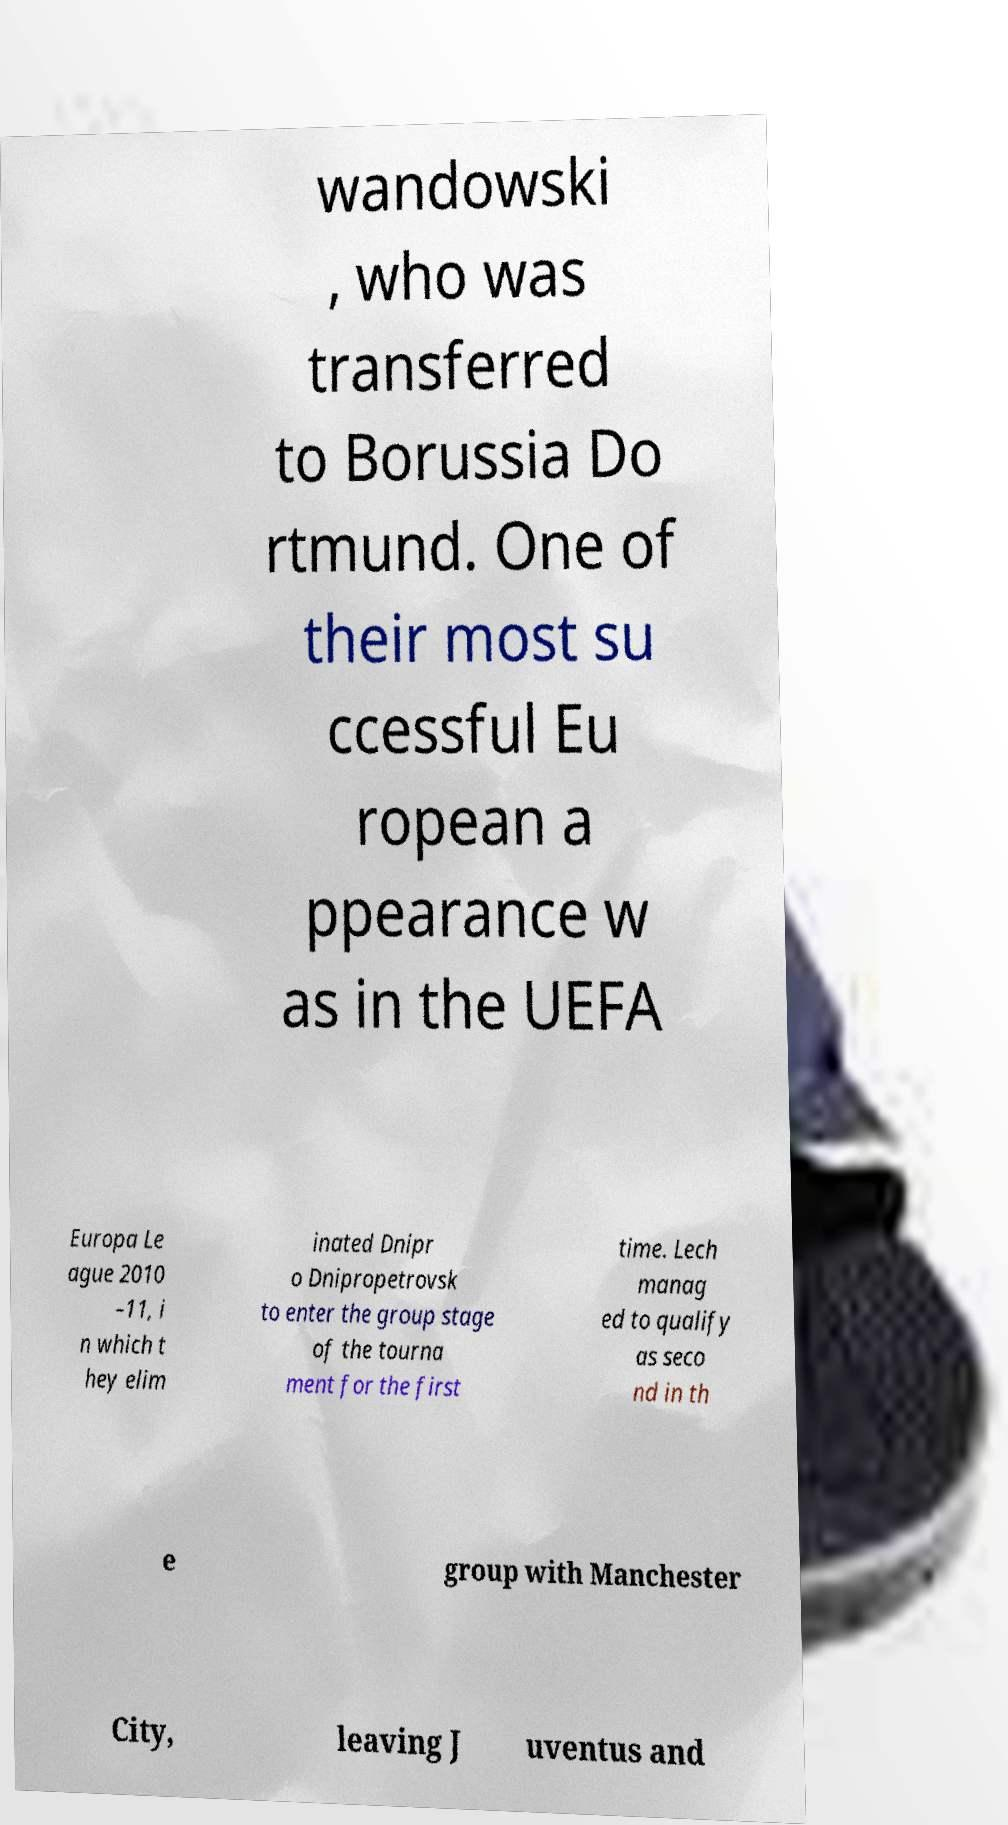Can you accurately transcribe the text from the provided image for me? wandowski , who was transferred to Borussia Do rtmund. One of their most su ccessful Eu ropean a ppearance w as in the UEFA Europa Le ague 2010 –11, i n which t hey elim inated Dnipr o Dnipropetrovsk to enter the group stage of the tourna ment for the first time. Lech manag ed to qualify as seco nd in th e group with Manchester City, leaving J uventus and 